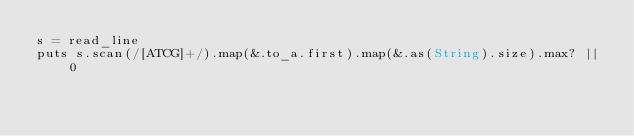<code> <loc_0><loc_0><loc_500><loc_500><_Crystal_>s = read_line
puts s.scan(/[ATCG]+/).map(&.to_a.first).map(&.as(String).size).max? || 0</code> 